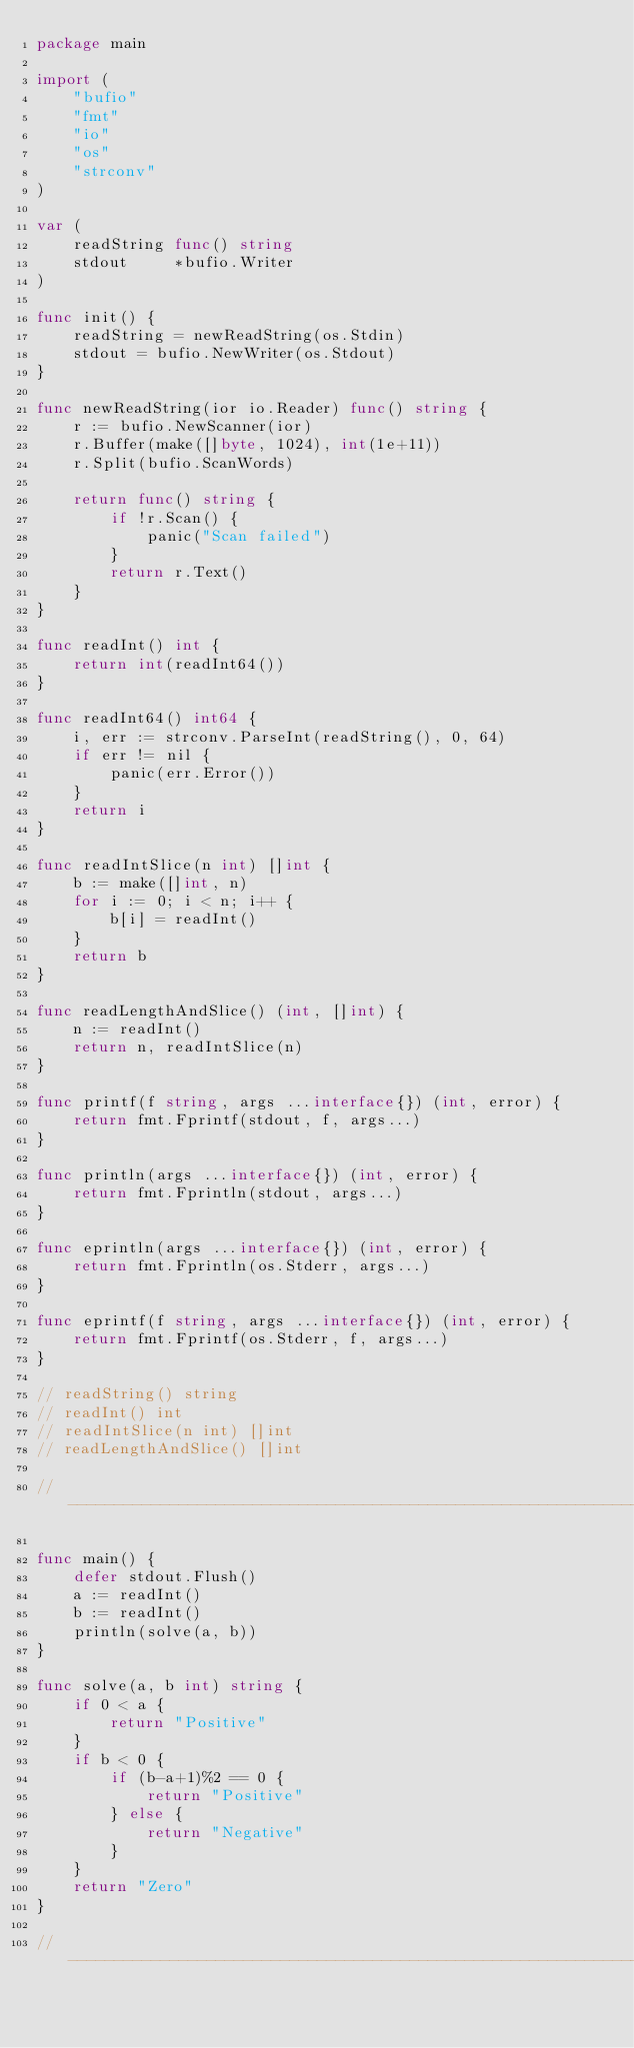<code> <loc_0><loc_0><loc_500><loc_500><_Go_>package main

import (
	"bufio"
	"fmt"
	"io"
	"os"
	"strconv"
)

var (
	readString func() string
	stdout     *bufio.Writer
)

func init() {
	readString = newReadString(os.Stdin)
	stdout = bufio.NewWriter(os.Stdout)
}

func newReadString(ior io.Reader) func() string {
	r := bufio.NewScanner(ior)
	r.Buffer(make([]byte, 1024), int(1e+11))
	r.Split(bufio.ScanWords)

	return func() string {
		if !r.Scan() {
			panic("Scan failed")
		}
		return r.Text()
	}
}

func readInt() int {
	return int(readInt64())
}

func readInt64() int64 {
	i, err := strconv.ParseInt(readString(), 0, 64)
	if err != nil {
		panic(err.Error())
	}
	return i
}

func readIntSlice(n int) []int {
	b := make([]int, n)
	for i := 0; i < n; i++ {
		b[i] = readInt()
	}
	return b
}

func readLengthAndSlice() (int, []int) {
	n := readInt()
	return n, readIntSlice(n)
}

func printf(f string, args ...interface{}) (int, error) {
	return fmt.Fprintf(stdout, f, args...)
}

func println(args ...interface{}) (int, error) {
	return fmt.Fprintln(stdout, args...)
}

func eprintln(args ...interface{}) (int, error) {
	return fmt.Fprintln(os.Stderr, args...)
}

func eprintf(f string, args ...interface{}) (int, error) {
	return fmt.Fprintf(os.Stderr, f, args...)
}

// readString() string
// readInt() int
// readIntSlice(n int) []int
// readLengthAndSlice() []int

// -----------------------------------------------------------------------------

func main() {
	defer stdout.Flush()
	a := readInt()
	b := readInt()
	println(solve(a, b))
}

func solve(a, b int) string {
	if 0 < a {
		return "Positive"
	}
	if b < 0 {
		if (b-a+1)%2 == 0 {
			return "Positive"
		} else {
			return "Negative"
		}
	}
	return "Zero"
}

// -----------------------------------------------------------------------------
</code> 